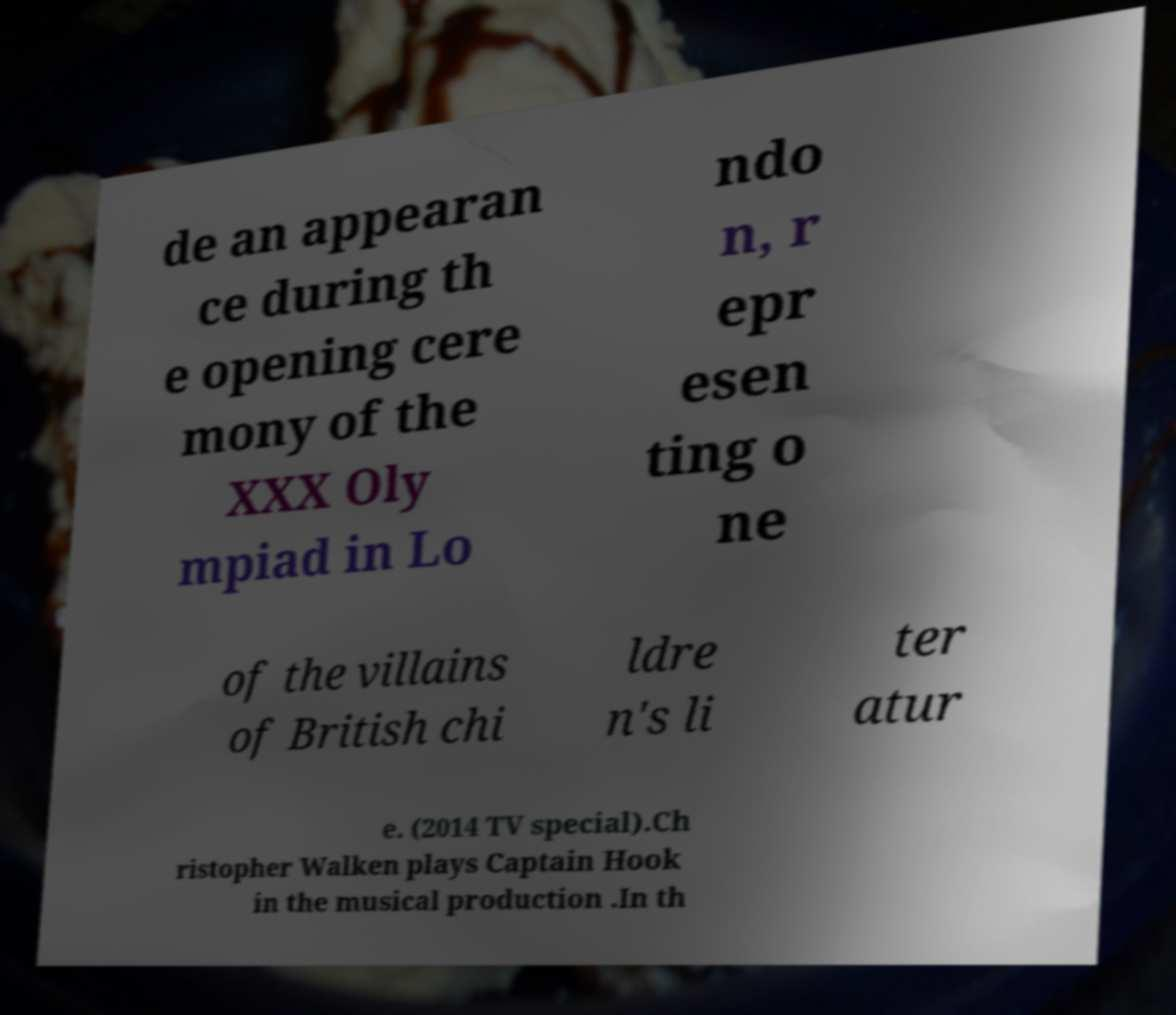For documentation purposes, I need the text within this image transcribed. Could you provide that? de an appearan ce during th e opening cere mony of the XXX Oly mpiad in Lo ndo n, r epr esen ting o ne of the villains of British chi ldre n's li ter atur e. (2014 TV special).Ch ristopher Walken plays Captain Hook in the musical production .In th 